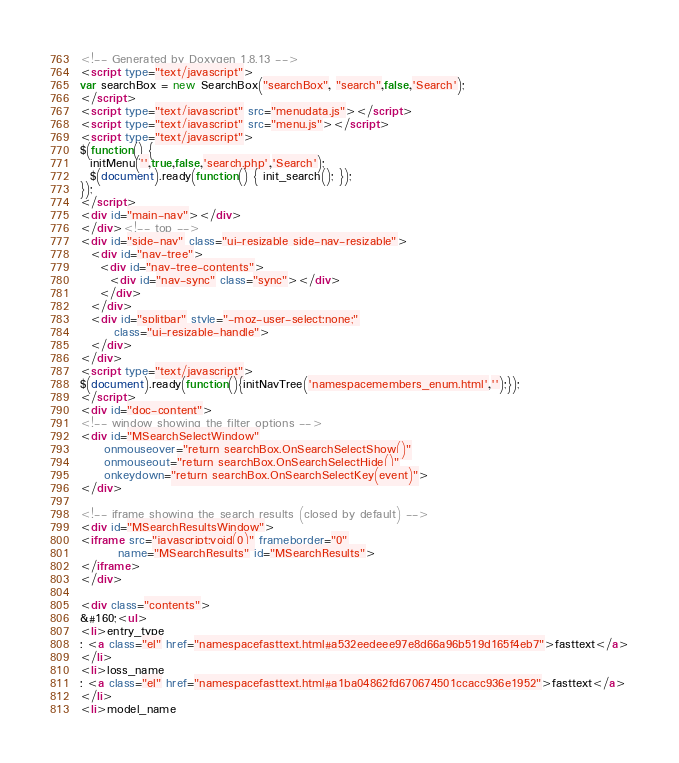<code> <loc_0><loc_0><loc_500><loc_500><_HTML_><!-- Generated by Doxygen 1.8.13 -->
<script type="text/javascript">
var searchBox = new SearchBox("searchBox", "search",false,'Search');
</script>
<script type="text/javascript" src="menudata.js"></script>
<script type="text/javascript" src="menu.js"></script>
<script type="text/javascript">
$(function() {
  initMenu('',true,false,'search.php','Search');
  $(document).ready(function() { init_search(); });
});
</script>
<div id="main-nav"></div>
</div><!-- top -->
<div id="side-nav" class="ui-resizable side-nav-resizable">
  <div id="nav-tree">
    <div id="nav-tree-contents">
      <div id="nav-sync" class="sync"></div>
    </div>
  </div>
  <div id="splitbar" style="-moz-user-select:none;" 
       class="ui-resizable-handle">
  </div>
</div>
<script type="text/javascript">
$(document).ready(function(){initNavTree('namespacemembers_enum.html','');});
</script>
<div id="doc-content">
<!-- window showing the filter options -->
<div id="MSearchSelectWindow"
     onmouseover="return searchBox.OnSearchSelectShow()"
     onmouseout="return searchBox.OnSearchSelectHide()"
     onkeydown="return searchBox.OnSearchSelectKey(event)">
</div>

<!-- iframe showing the search results (closed by default) -->
<div id="MSearchResultsWindow">
<iframe src="javascript:void(0)" frameborder="0" 
        name="MSearchResults" id="MSearchResults">
</iframe>
</div>

<div class="contents">
&#160;<ul>
<li>entry_type
: <a class="el" href="namespacefasttext.html#a532eedeee97e8d66a96b519d165f4eb7">fasttext</a>
</li>
<li>loss_name
: <a class="el" href="namespacefasttext.html#a1ba04862fd670674501ccacc936e1952">fasttext</a>
</li>
<li>model_name</code> 